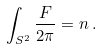Convert formula to latex. <formula><loc_0><loc_0><loc_500><loc_500>\int _ { S ^ { 2 } } \frac { F } { 2 \pi } = n \, .</formula> 